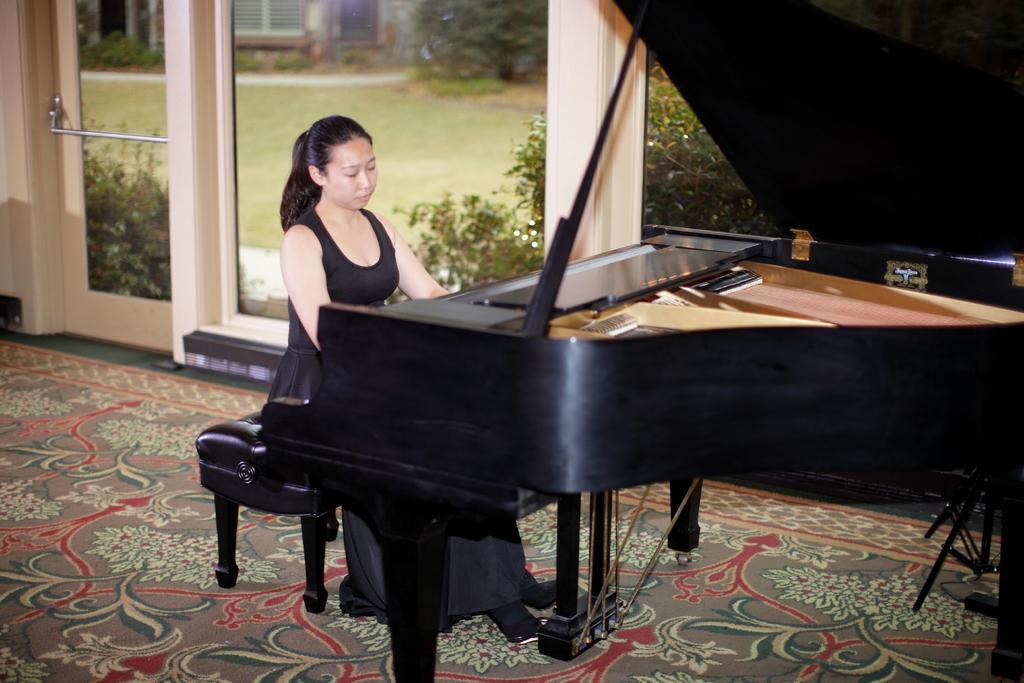Could you give a brief overview of what you see in this image? In this image there is a woman playing a piano, and she is wearing a black colored dress. At the bottom there is floor mat with nice design. In the background there is a door and a glass through which the garden is seen. 